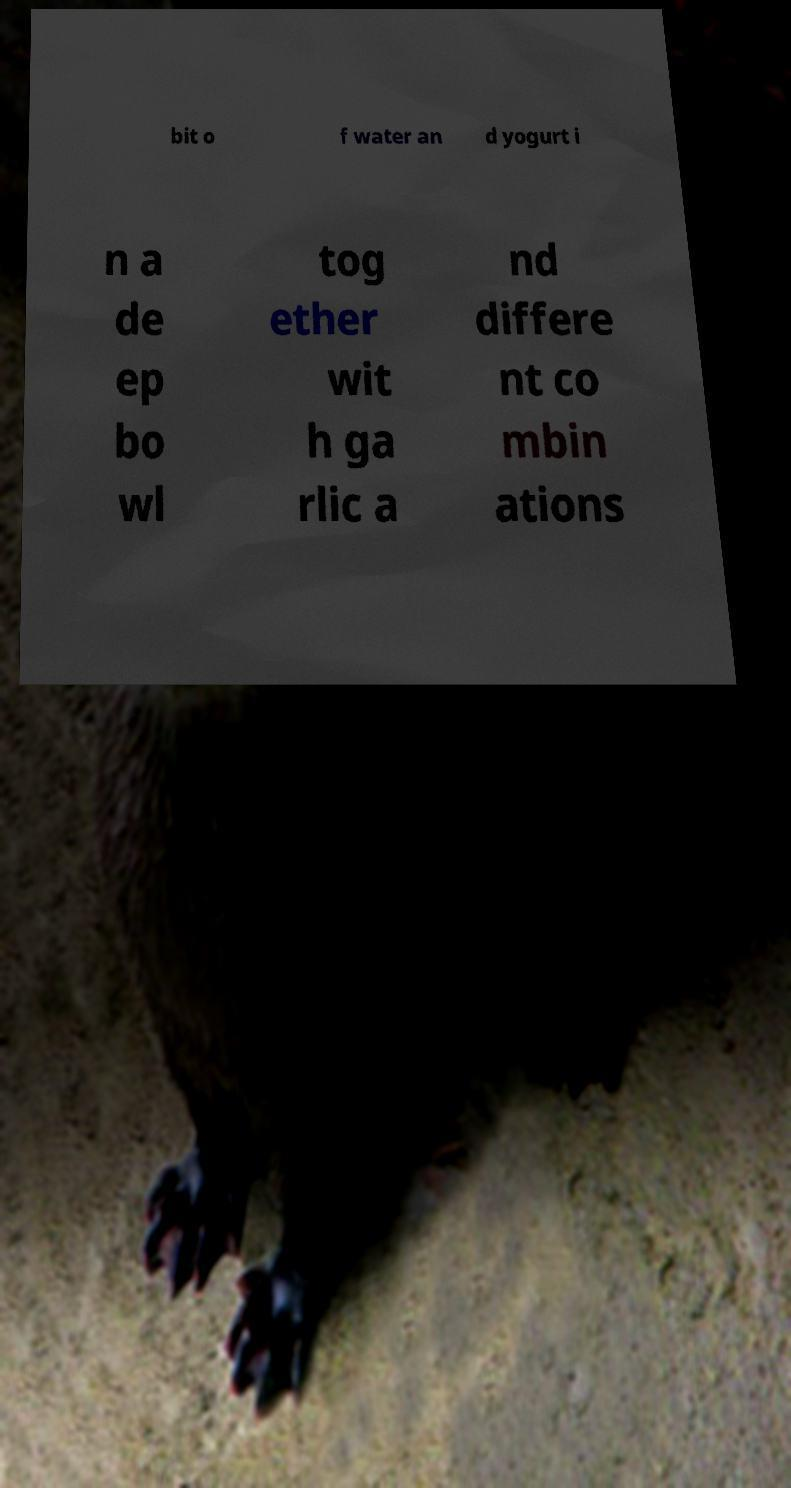Can you read and provide the text displayed in the image?This photo seems to have some interesting text. Can you extract and type it out for me? bit o f water an d yogurt i n a de ep bo wl tog ether wit h ga rlic a nd differe nt co mbin ations 